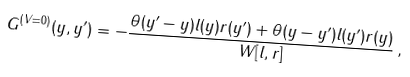Convert formula to latex. <formula><loc_0><loc_0><loc_500><loc_500>G ^ { ( V = 0 ) } ( y , y ^ { \prime } ) = - \frac { \theta ( y ^ { \prime } - y ) l ( y ) r ( y ^ { \prime } ) + \theta ( y - y ^ { \prime } ) l ( y ^ { \prime } ) r ( y ) } { W [ l , r ] } \, ,</formula> 